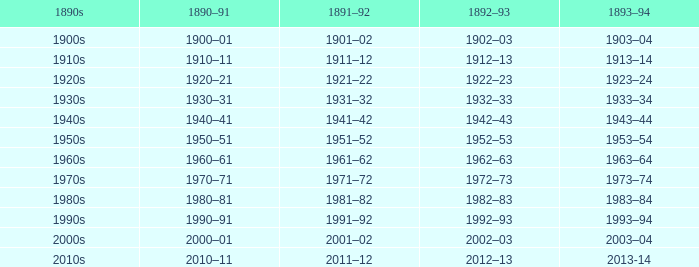What years from 1893-94 that is from the 1890s to the 1990s? 1993–94. 